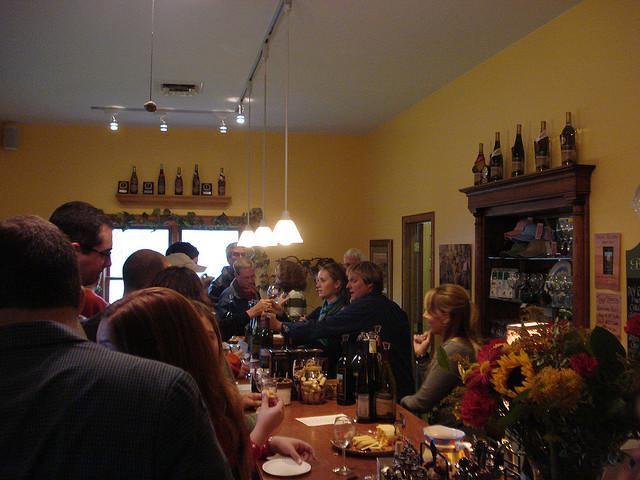How many lights are hanging from the ceiling?
Answer briefly. 7. Are these people at work?
Answer briefly. No. Where is there a row of 8 hanging lights?
Answer briefly. Ceiling. Where are the bottles displayed?
Give a very brief answer. Shelf. Are there wine bottles on the table?
Be succinct. Yes. Is this an airport?
Quick response, please. No. How many of these possible could be drinking the wine?
Be succinct. All. 